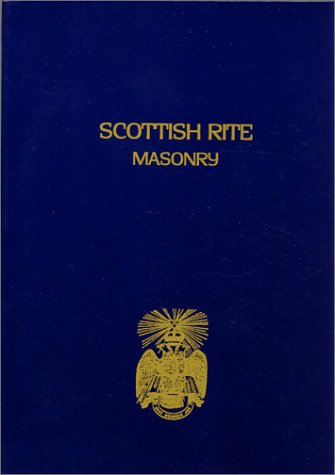Is this book related to Religion & Spirituality? Yes, this book is deeply related to Religion & Spirituality, exploring complex subjects of Scottish Rite Masonry, a notable order within Freemasonry. 